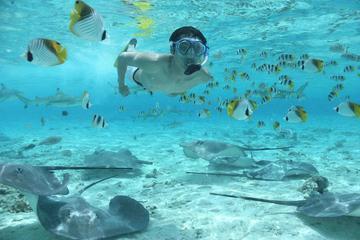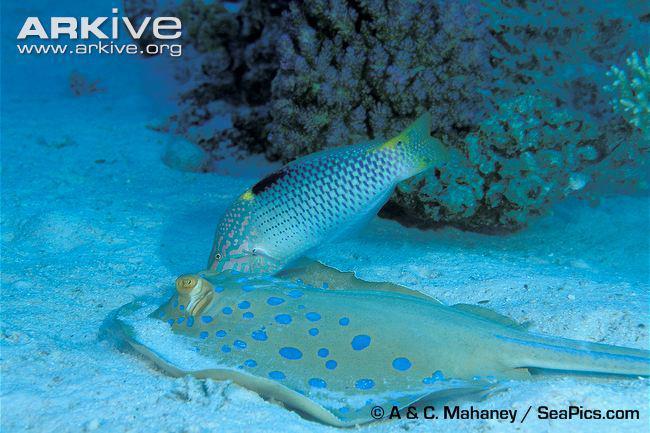The first image is the image on the left, the second image is the image on the right. Assess this claim about the two images: "Hands are extended toward a stingray in at least one image, and an image shows at least two people in the water with a stingray.". Correct or not? Answer yes or no. No. The first image is the image on the left, the second image is the image on the right. Evaluate the accuracy of this statement regarding the images: "there are 3 stingrays in the image pair". Is it true? Answer yes or no. No. 